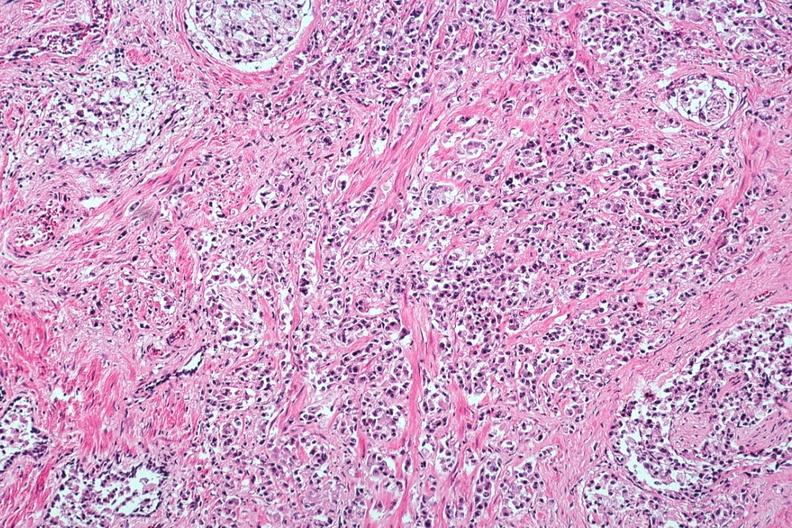does this image show typical infiltrating carcinoma with perineural invasion?
Answer the question using a single word or phrase. Yes 